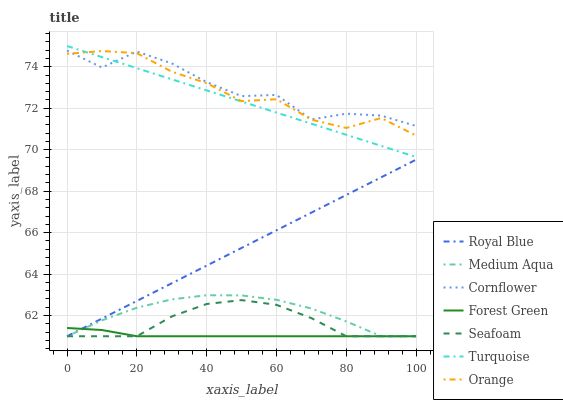Does Forest Green have the minimum area under the curve?
Answer yes or no. Yes. Does Cornflower have the maximum area under the curve?
Answer yes or no. Yes. Does Turquoise have the minimum area under the curve?
Answer yes or no. No. Does Turquoise have the maximum area under the curve?
Answer yes or no. No. Is Royal Blue the smoothest?
Answer yes or no. Yes. Is Cornflower the roughest?
Answer yes or no. Yes. Is Turquoise the smoothest?
Answer yes or no. No. Is Turquoise the roughest?
Answer yes or no. No. Does Seafoam have the lowest value?
Answer yes or no. Yes. Does Turquoise have the lowest value?
Answer yes or no. No. Does Turquoise have the highest value?
Answer yes or no. Yes. Does Seafoam have the highest value?
Answer yes or no. No. Is Seafoam less than Orange?
Answer yes or no. Yes. Is Cornflower greater than Medium Aqua?
Answer yes or no. Yes. Does Orange intersect Cornflower?
Answer yes or no. Yes. Is Orange less than Cornflower?
Answer yes or no. No. Is Orange greater than Cornflower?
Answer yes or no. No. Does Seafoam intersect Orange?
Answer yes or no. No. 